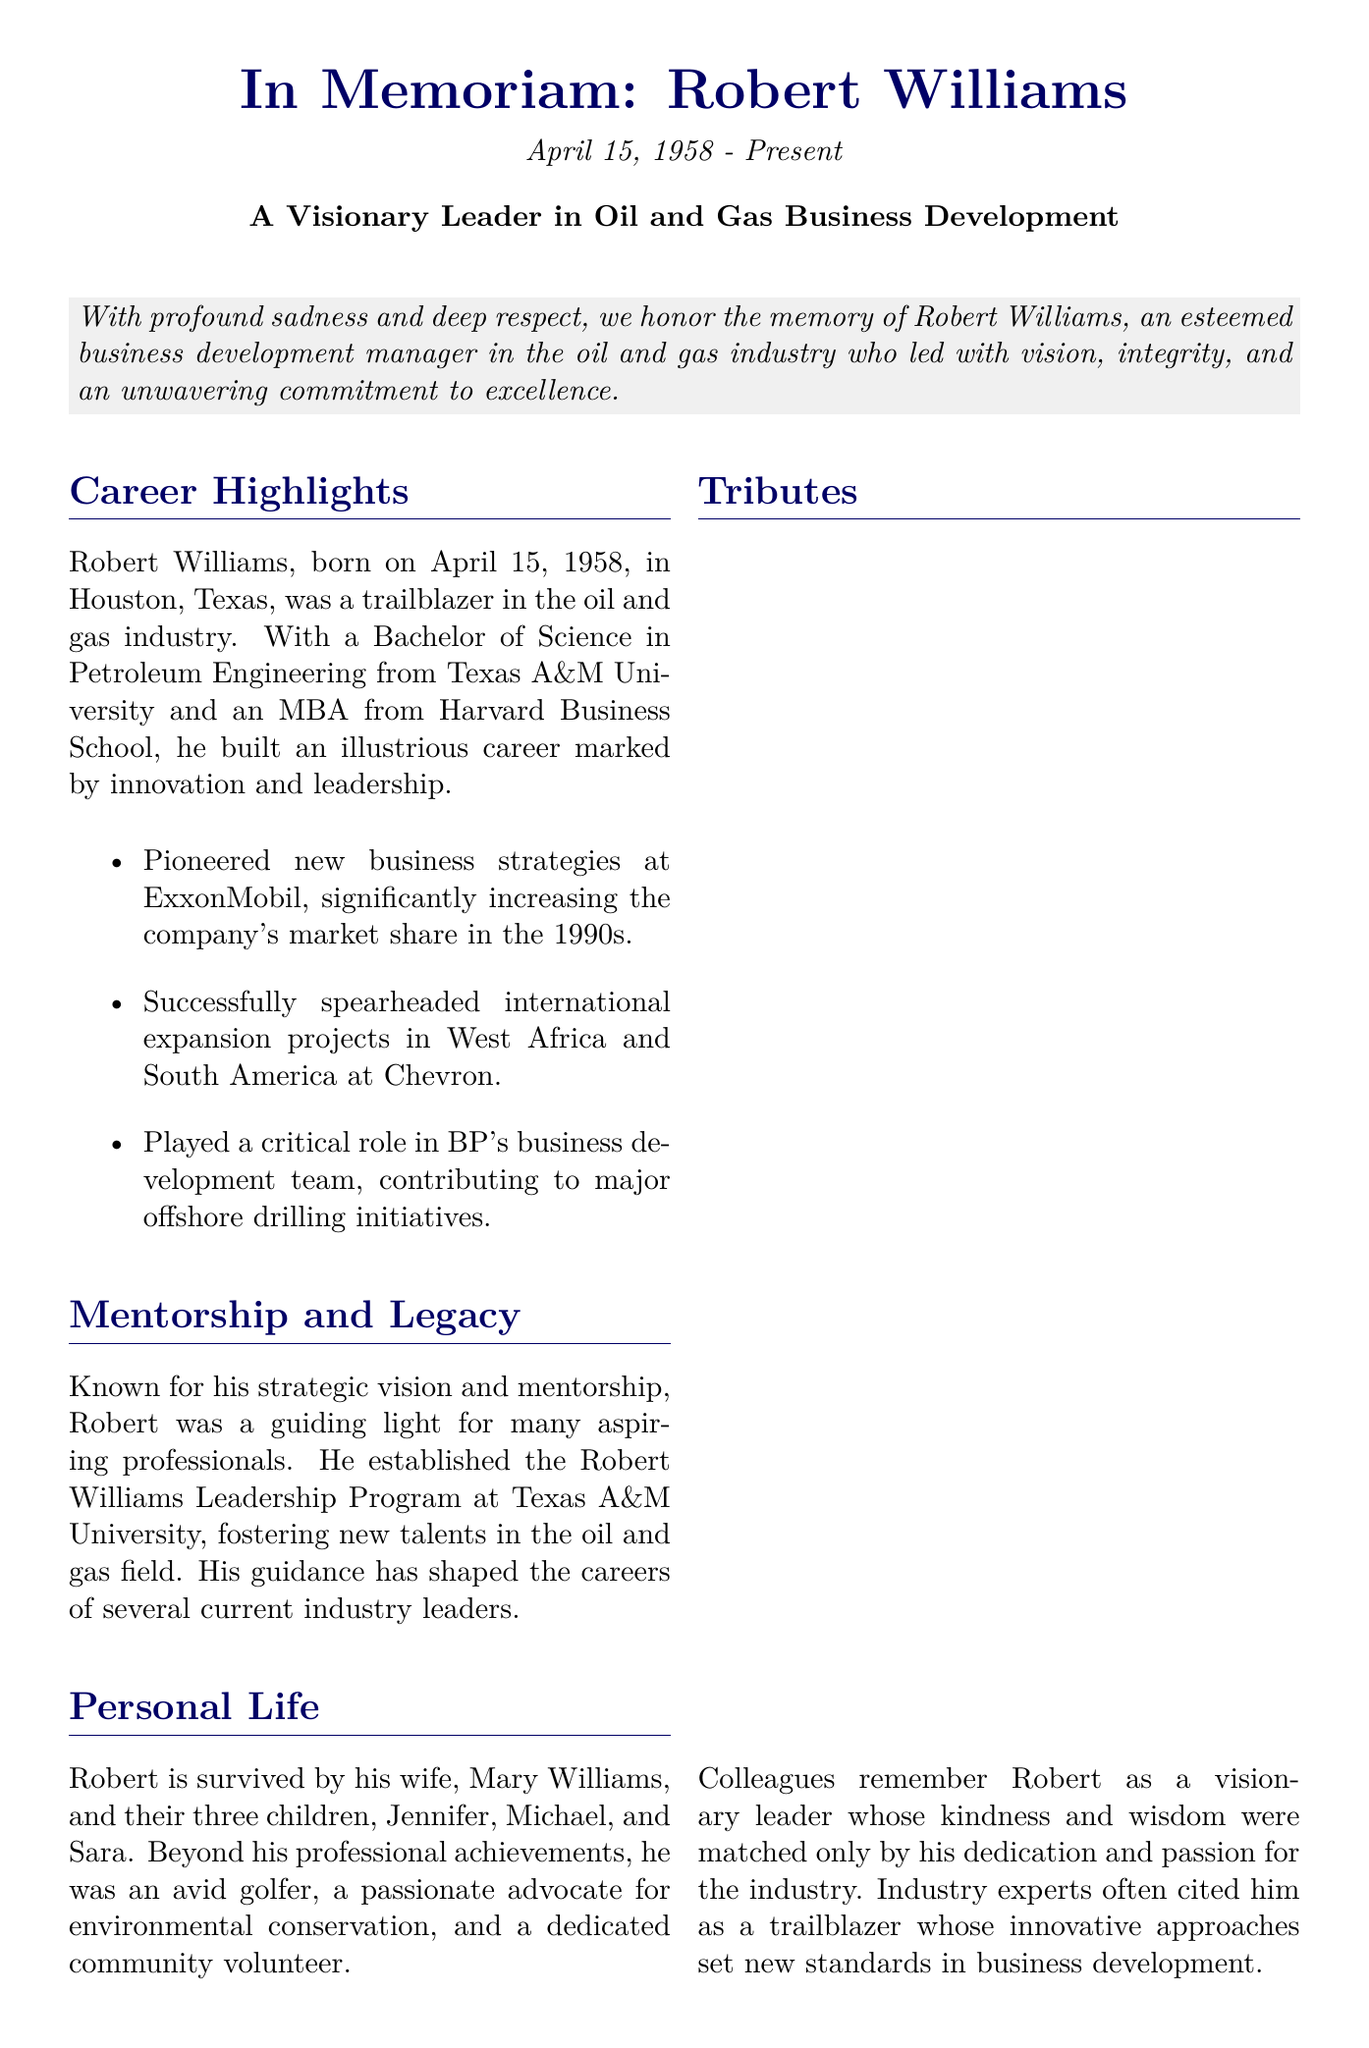What was Robert Williams' date of birth? The document states that Robert Williams was born on April 15, 1958.
Answer: April 15, 1958 What degree did Robert Williams earn from Texas A&M University? The document mentions he earned a Bachelor of Science in Petroleum Engineering from Texas A&M University.
Answer: Bachelor of Science in Petroleum Engineering Which university awarded Robert an MBA? The document states that he earned an MBA from Harvard Business School.
Answer: Harvard Business School What leadership program did Robert Williams establish? The document indicates that he established the Robert Williams Leadership Program at Texas A&M University.
Answer: Robert Williams Leadership Program What was one of Robert's hobbies mentioned in the obituary? The document states that he was an avid golfer.
Answer: Golfer In which regions did Robert spearhead international expansion projects? The document reveals that he led international expansion projects in West Africa and South America.
Answer: West Africa and South America How many children did Robert Williams have? The document states that he had three children: Jennifer, Michael, and Sara.
Answer: Three What was noted as a defining characteristic of Robert's leadership style? The document describes Robert's kindness and wisdom as defining characteristics of his leadership style.
Answer: Kindness and wisdom What lasting impact did Robert Williams have on the industry? The document mentions that his spirit of innovation and commitment to mentoring will inspire future generations.
Answer: Inspire future generations 